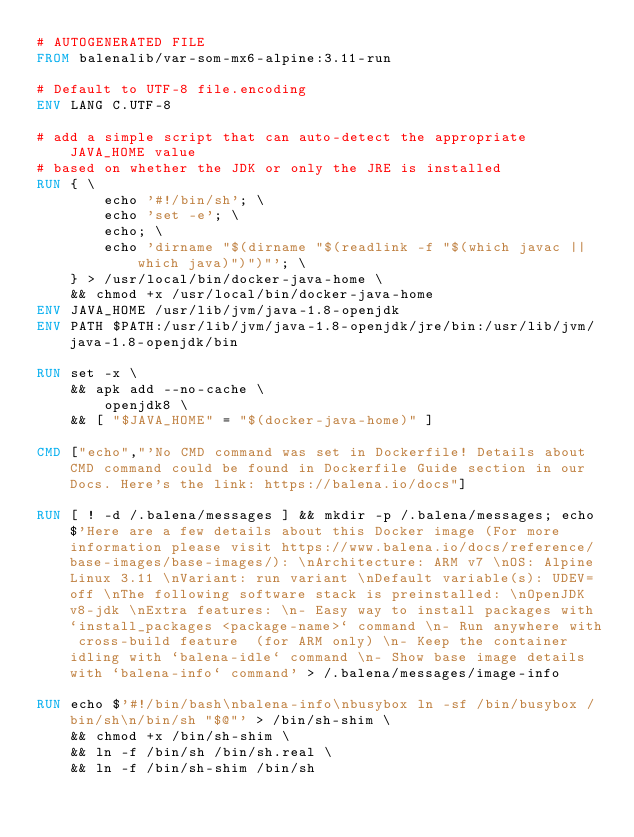<code> <loc_0><loc_0><loc_500><loc_500><_Dockerfile_># AUTOGENERATED FILE
FROM balenalib/var-som-mx6-alpine:3.11-run

# Default to UTF-8 file.encoding
ENV LANG C.UTF-8

# add a simple script that can auto-detect the appropriate JAVA_HOME value
# based on whether the JDK or only the JRE is installed
RUN { \
		echo '#!/bin/sh'; \
		echo 'set -e'; \
		echo; \
		echo 'dirname "$(dirname "$(readlink -f "$(which javac || which java)")")"'; \
	} > /usr/local/bin/docker-java-home \
	&& chmod +x /usr/local/bin/docker-java-home
ENV JAVA_HOME /usr/lib/jvm/java-1.8-openjdk
ENV PATH $PATH:/usr/lib/jvm/java-1.8-openjdk/jre/bin:/usr/lib/jvm/java-1.8-openjdk/bin

RUN set -x \
	&& apk add --no-cache \
		openjdk8 \
	&& [ "$JAVA_HOME" = "$(docker-java-home)" ]

CMD ["echo","'No CMD command was set in Dockerfile! Details about CMD command could be found in Dockerfile Guide section in our Docs. Here's the link: https://balena.io/docs"]

RUN [ ! -d /.balena/messages ] && mkdir -p /.balena/messages; echo $'Here are a few details about this Docker image (For more information please visit https://www.balena.io/docs/reference/base-images/base-images/): \nArchitecture: ARM v7 \nOS: Alpine Linux 3.11 \nVariant: run variant \nDefault variable(s): UDEV=off \nThe following software stack is preinstalled: \nOpenJDK v8-jdk \nExtra features: \n- Easy way to install packages with `install_packages <package-name>` command \n- Run anywhere with cross-build feature  (for ARM only) \n- Keep the container idling with `balena-idle` command \n- Show base image details with `balena-info` command' > /.balena/messages/image-info

RUN echo $'#!/bin/bash\nbalena-info\nbusybox ln -sf /bin/busybox /bin/sh\n/bin/sh "$@"' > /bin/sh-shim \
	&& chmod +x /bin/sh-shim \
	&& ln -f /bin/sh /bin/sh.real \
	&& ln -f /bin/sh-shim /bin/sh</code> 